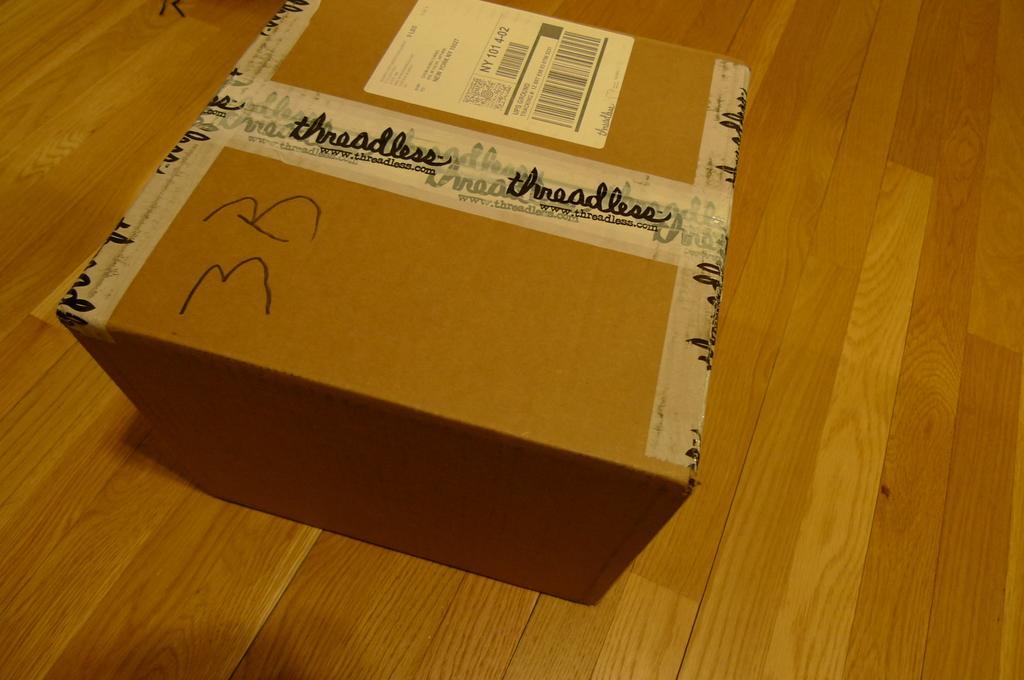Can you describe this image briefly? In this picture there is a cartoon box in the center of the image. 